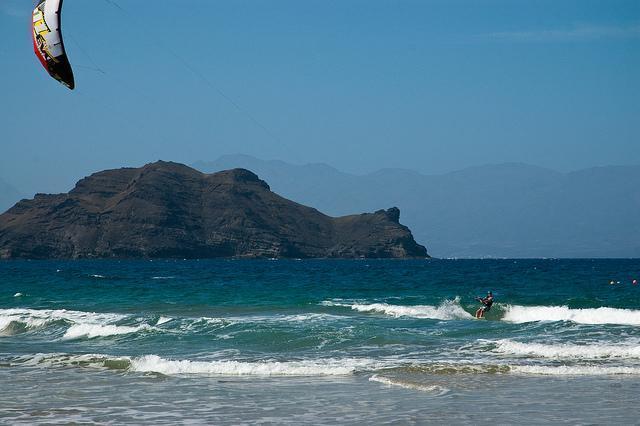What is he doing?
Indicate the correct response by choosing from the four available options to answer the question.
Options: Swimming, resting, skiing, wind surfing. Wind surfing. 